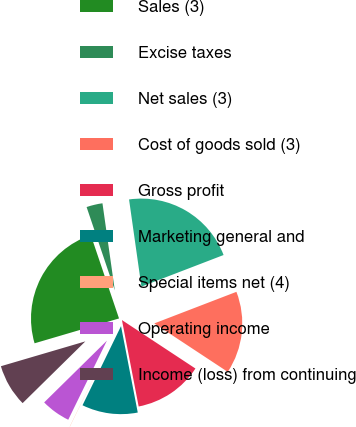Convert chart to OTSL. <chart><loc_0><loc_0><loc_500><loc_500><pie_chart><fcel>Sales (3)<fcel>Excise taxes<fcel>Net sales (3)<fcel>Cost of goods sold (3)<fcel>Gross profit<fcel>Marketing general and<fcel>Special items net (4)<fcel>Operating income<fcel>Income (loss) from continuing<nl><fcel>24.36%<fcel>2.95%<fcel>21.4%<fcel>15.12%<fcel>12.68%<fcel>10.25%<fcel>0.03%<fcel>5.39%<fcel>7.82%<nl></chart> 